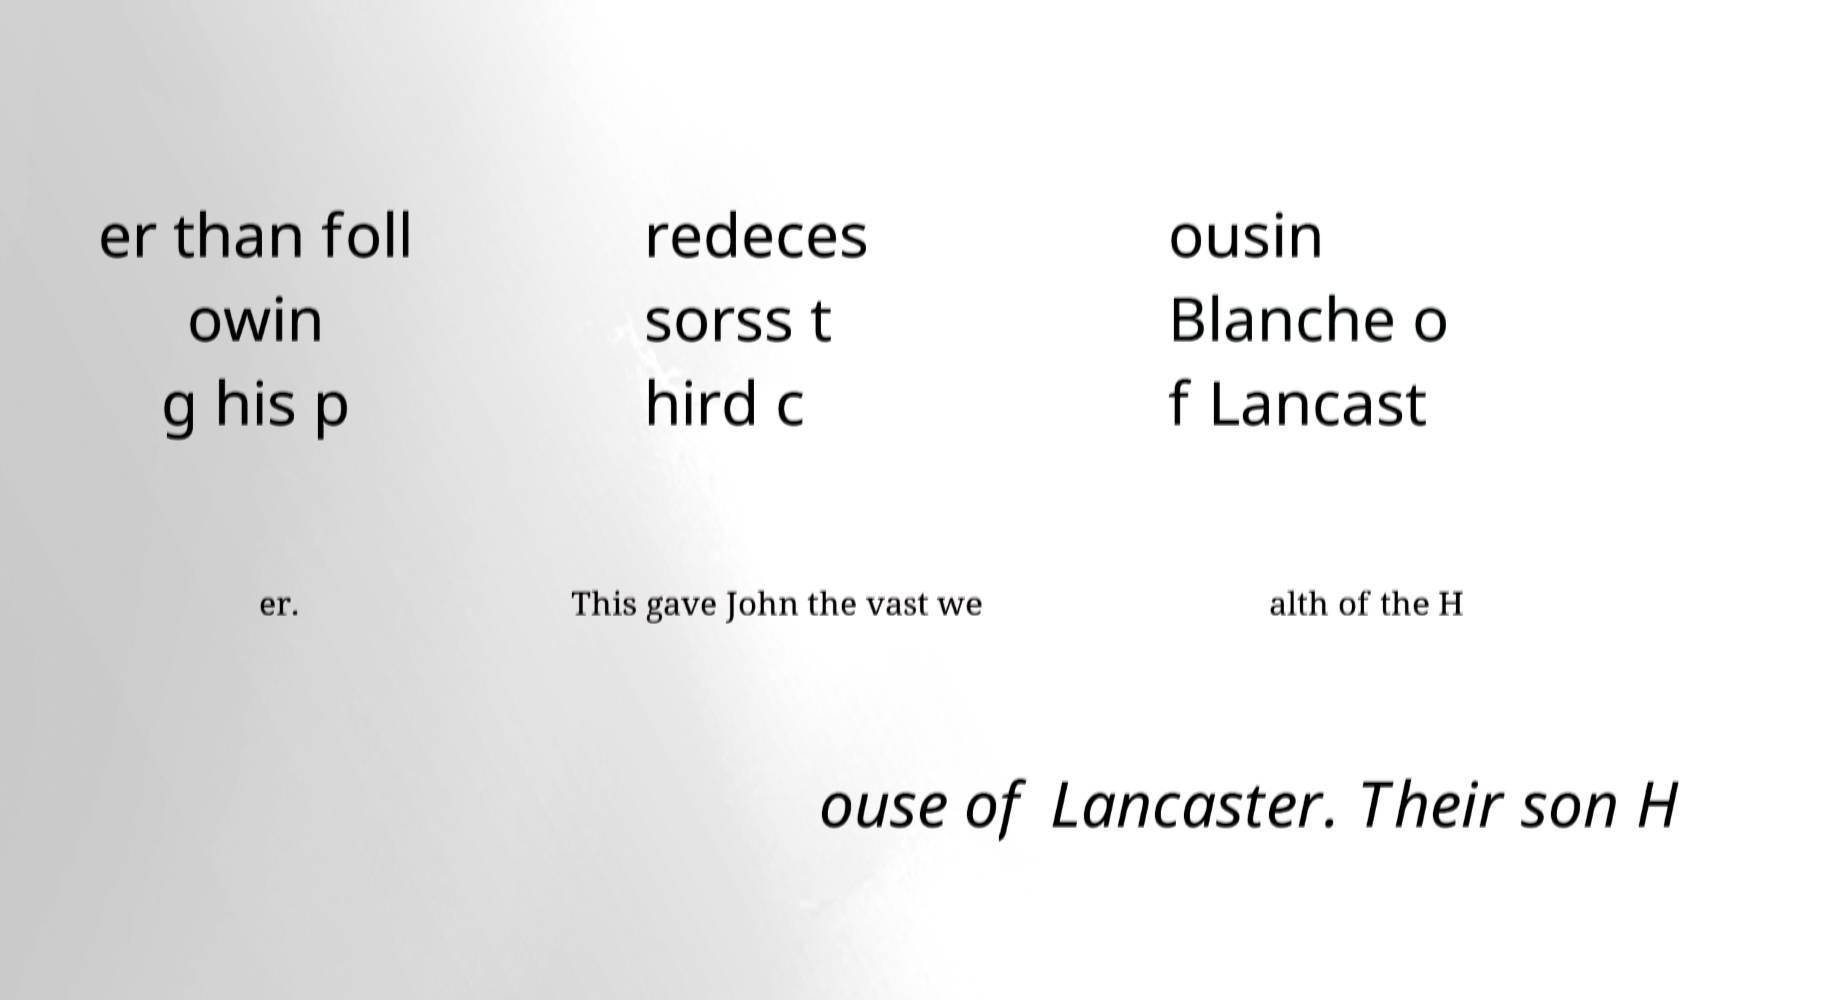Can you read and provide the text displayed in the image?This photo seems to have some interesting text. Can you extract and type it out for me? er than foll owin g his p redeces sorss t hird c ousin Blanche o f Lancast er. This gave John the vast we alth of the H ouse of Lancaster. Their son H 